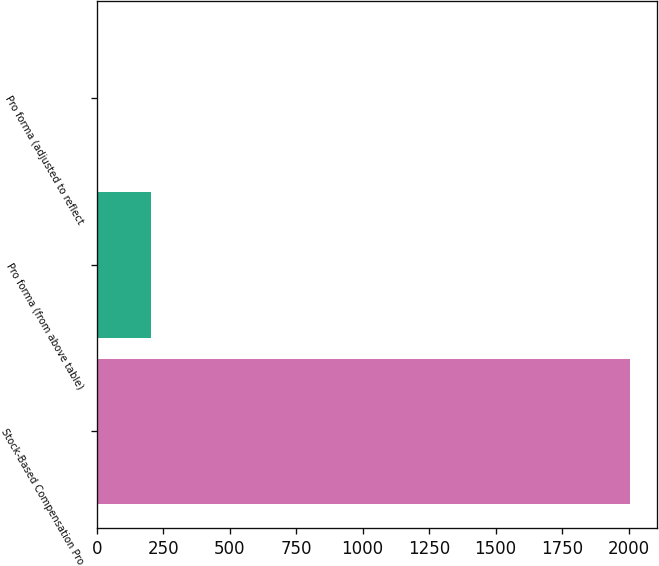Convert chart. <chart><loc_0><loc_0><loc_500><loc_500><bar_chart><fcel>Stock-Based Compensation Pro<fcel>Pro forma (from above table)<fcel>Pro forma (adjusted to reflect<nl><fcel>2005<fcel>204.06<fcel>3.96<nl></chart> 